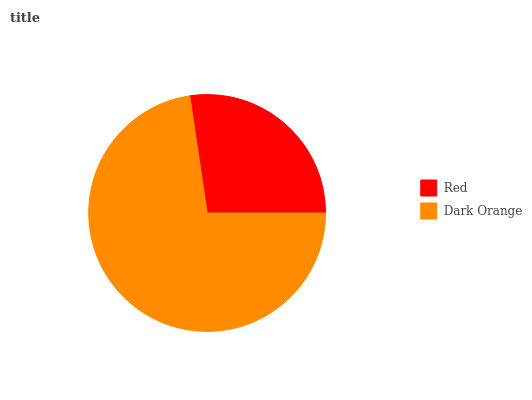Is Red the minimum?
Answer yes or no. Yes. Is Dark Orange the maximum?
Answer yes or no. Yes. Is Dark Orange the minimum?
Answer yes or no. No. Is Dark Orange greater than Red?
Answer yes or no. Yes. Is Red less than Dark Orange?
Answer yes or no. Yes. Is Red greater than Dark Orange?
Answer yes or no. No. Is Dark Orange less than Red?
Answer yes or no. No. Is Dark Orange the high median?
Answer yes or no. Yes. Is Red the low median?
Answer yes or no. Yes. Is Red the high median?
Answer yes or no. No. Is Dark Orange the low median?
Answer yes or no. No. 